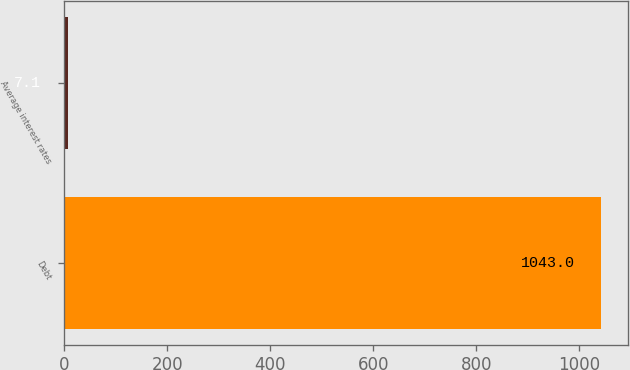Convert chart to OTSL. <chart><loc_0><loc_0><loc_500><loc_500><bar_chart><fcel>Debt<fcel>Average interest rates<nl><fcel>1043<fcel>7.1<nl></chart> 